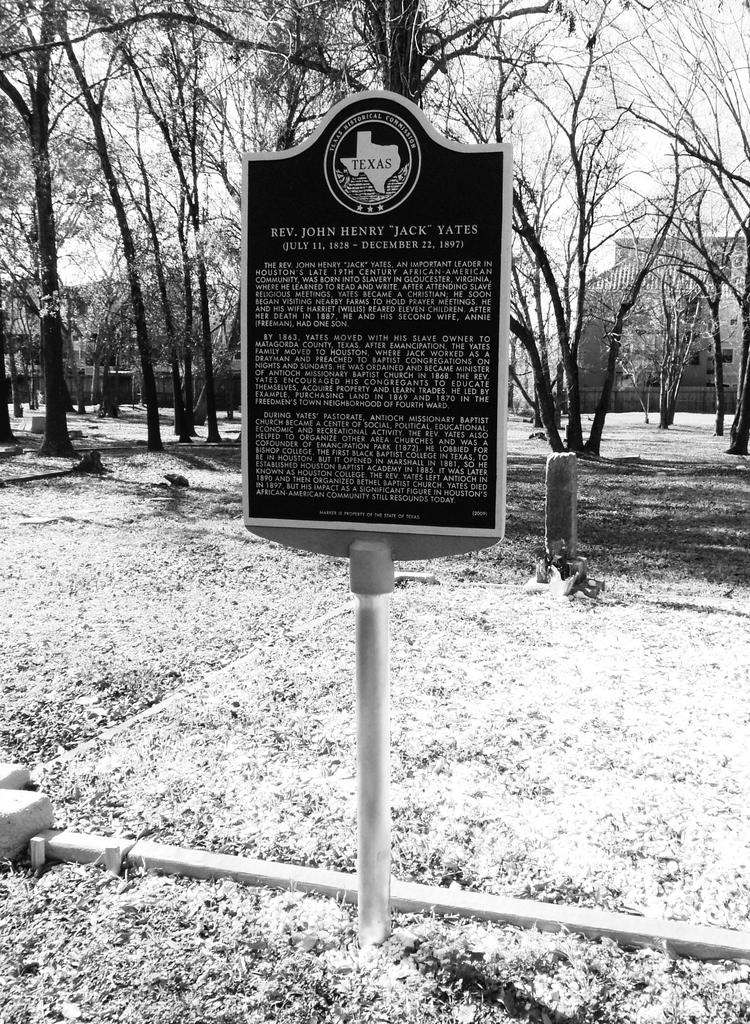What is the color scheme of the image? The image is black and white. What can be seen in the foreground of the image? There are dry leaves and a hoarding in the foreground of the image. What is visible in the background of the image? There are trees, buildings, and a pole in the background of the image. What is the weather like in the image? It is a sunny day. What type of glue is being used to stick the note to the pole in the image? There is no glue or note present in the image; it only features dry leaves, a hoarding, trees, buildings, and a pole. 